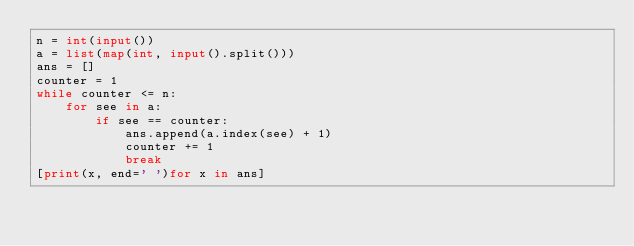Convert code to text. <code><loc_0><loc_0><loc_500><loc_500><_Python_>n = int(input())
a = list(map(int, input().split()))
ans = []
counter = 1
while counter <= n:
    for see in a:
        if see == counter:
            ans.append(a.index(see) + 1)
            counter += 1
            break
[print(x, end=' ')for x in ans]
</code> 